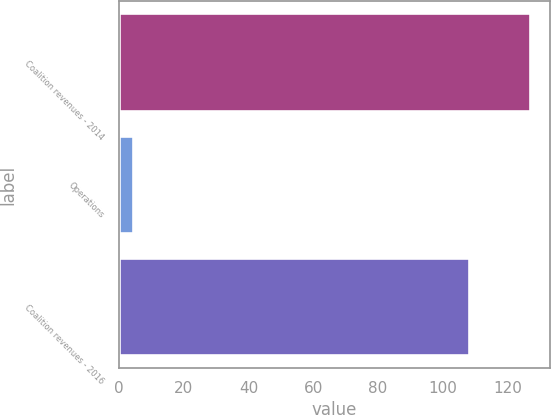Convert chart. <chart><loc_0><loc_0><loc_500><loc_500><bar_chart><fcel>Coalition revenues - 2014<fcel>Operations<fcel>Coalition revenues - 2016<nl><fcel>126.7<fcel>4.3<fcel>108.1<nl></chart> 